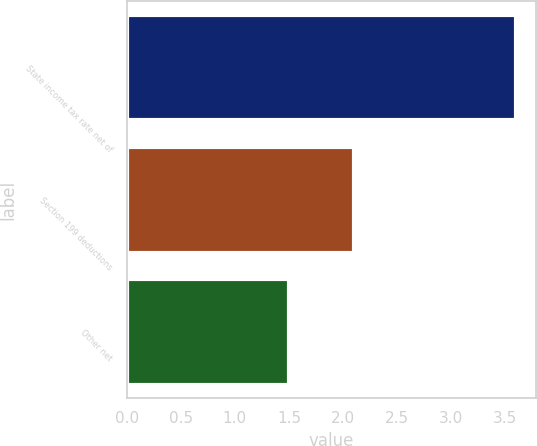Convert chart. <chart><loc_0><loc_0><loc_500><loc_500><bar_chart><fcel>State income tax rate net of<fcel>Section 199 deductions<fcel>Other net<nl><fcel>3.6<fcel>2.1<fcel>1.5<nl></chart> 